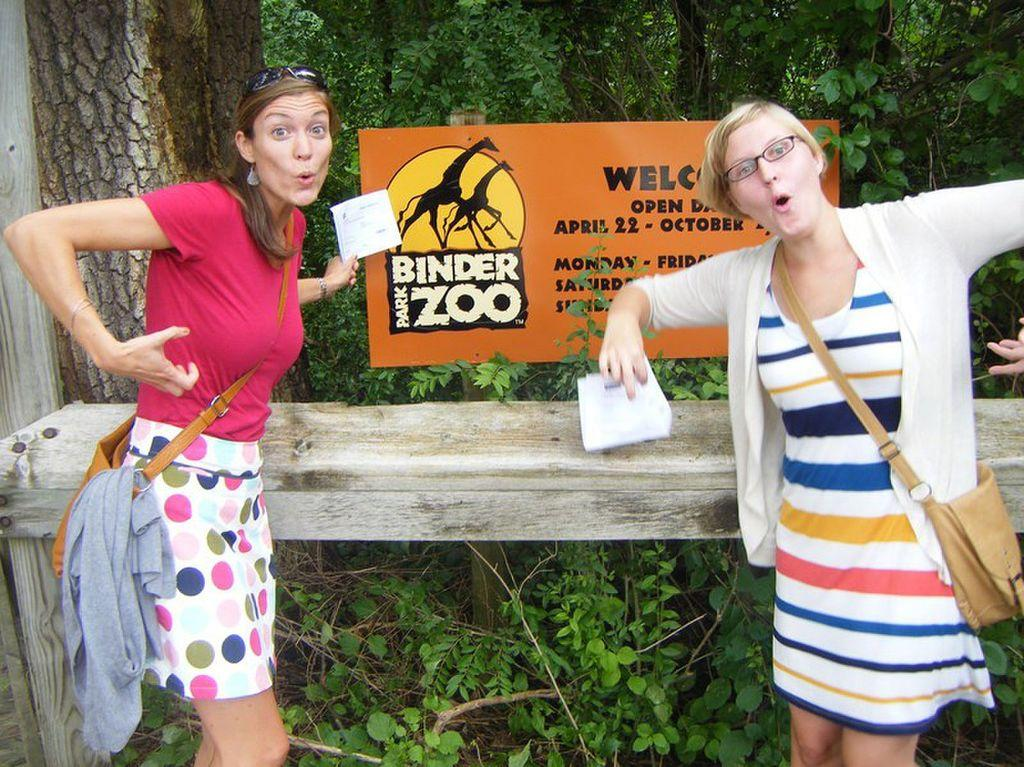How many people are in the image? There are two ladies in the image. What are the ladies wearing? The ladies are wearing bags. What are the ladies holding? The ladies are holding papers. What can be seen in the background of the image? There is a board, a table, and trees in the background of the image. Can you tell me how many hens are sitting on the table in the image? There are no hens present in the image; the table in the background is empty. 